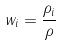<formula> <loc_0><loc_0><loc_500><loc_500>w _ { i } = \frac { \rho _ { i } } { \rho }</formula> 